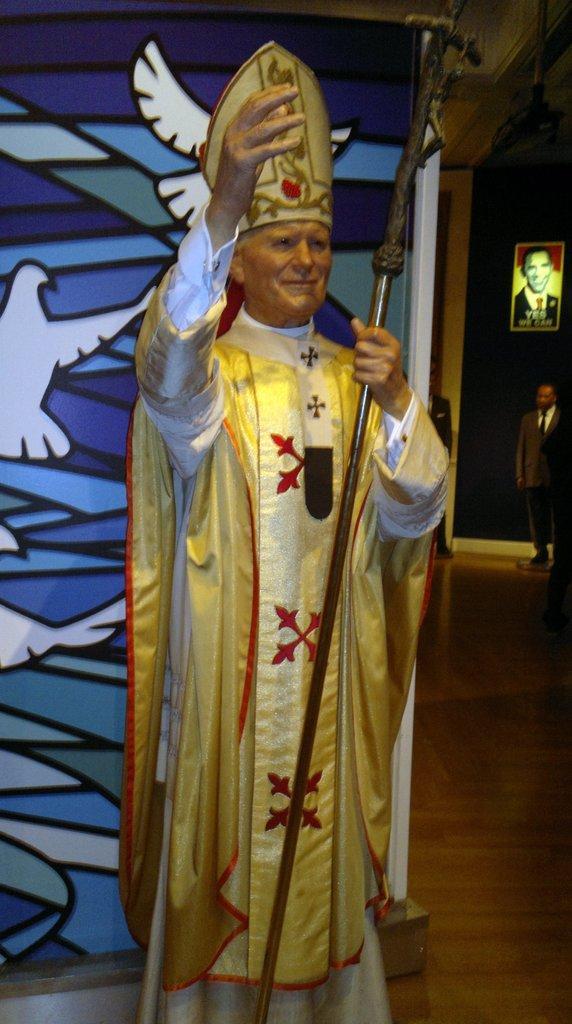How would you summarize this image in a sentence or two? In this picture we can see statue of a man standing and holding a stick, behind this statue we can see painting of an object. In the background of the image there is a man standing and we can see floor and frame on the wall. 